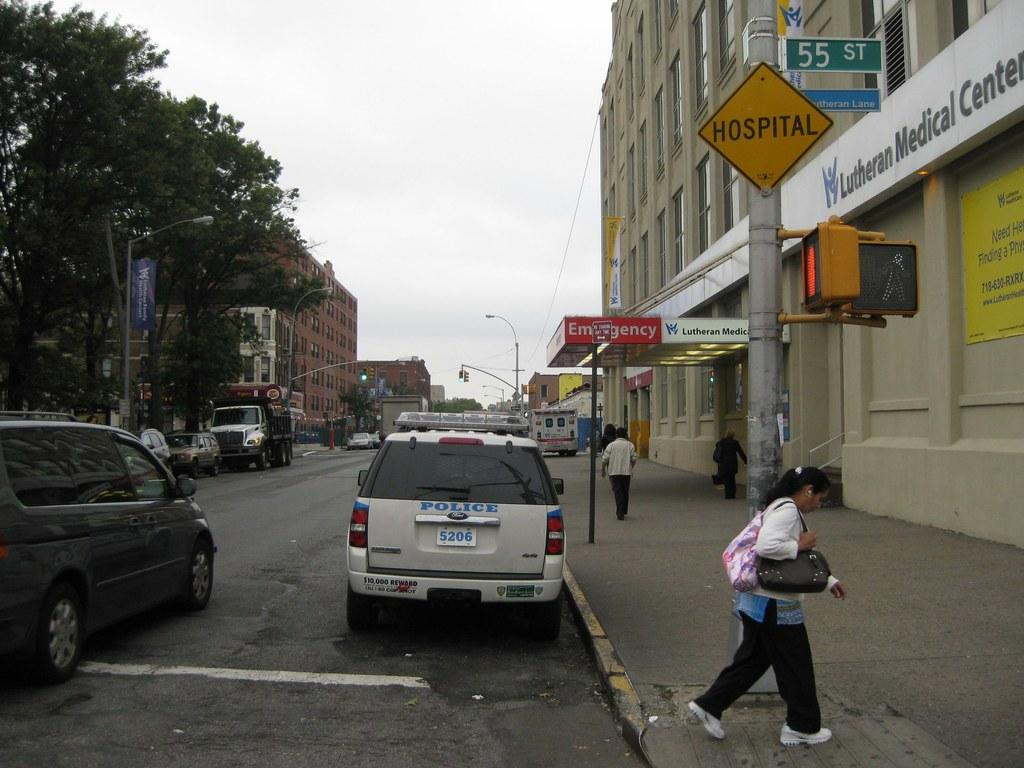<image>
Summarize the visual content of the image. a car that has the word police on the back 